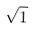<formula> <loc_0><loc_0><loc_500><loc_500>\sqrt { 1 }</formula> 